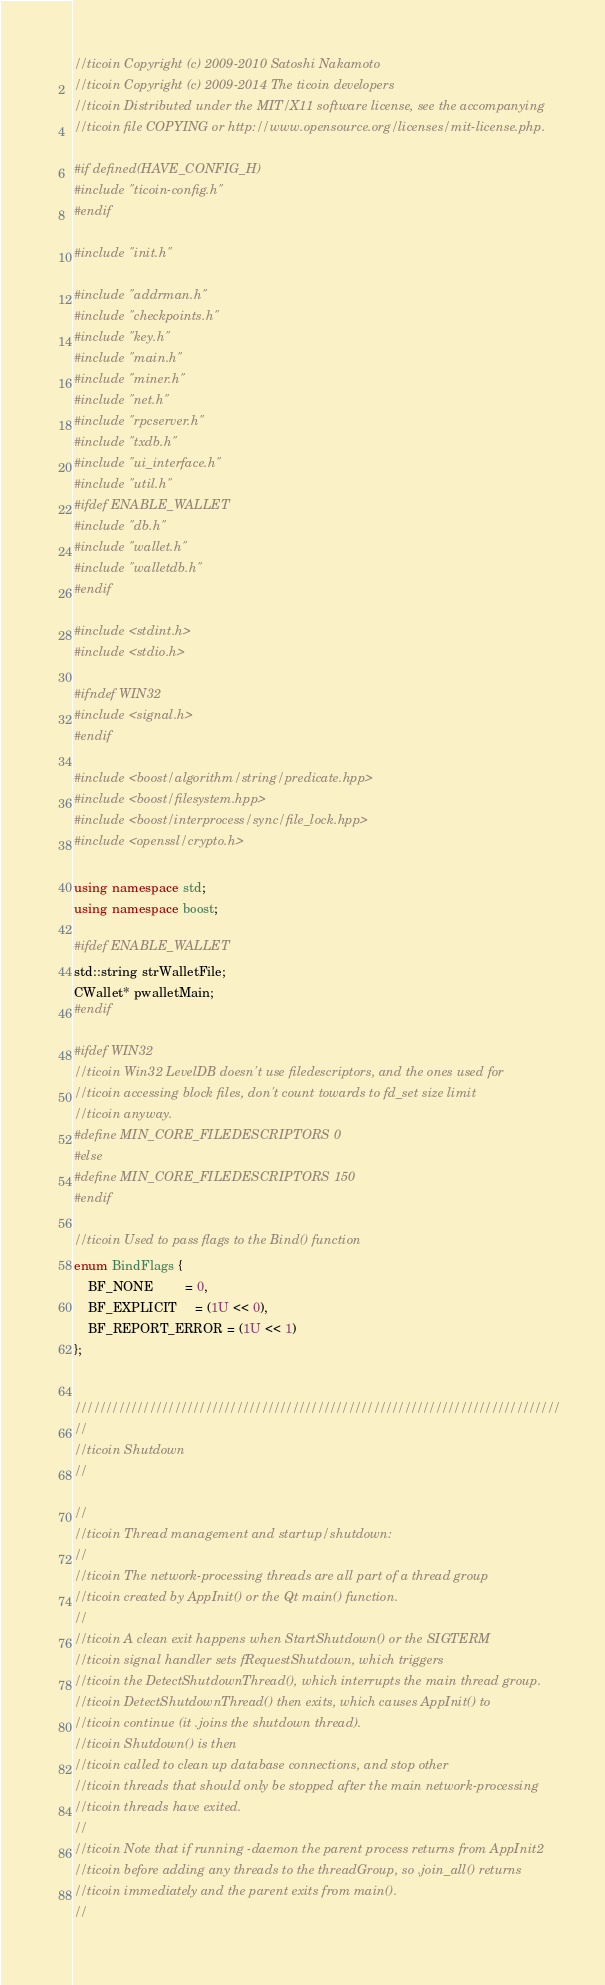<code> <loc_0><loc_0><loc_500><loc_500><_C++_>//ticoin Copyright (c) 2009-2010 Satoshi Nakamoto
//ticoin Copyright (c) 2009-2014 The ticoin developers
//ticoin Distributed under the MIT/X11 software license, see the accompanying
//ticoin file COPYING or http://www.opensource.org/licenses/mit-license.php.

#if defined(HAVE_CONFIG_H)
#include "ticoin-config.h"
#endif

#include "init.h"

#include "addrman.h"
#include "checkpoints.h"
#include "key.h"
#include "main.h"
#include "miner.h"
#include "net.h"
#include "rpcserver.h"
#include "txdb.h"
#include "ui_interface.h"
#include "util.h"
#ifdef ENABLE_WALLET
#include "db.h"
#include "wallet.h"
#include "walletdb.h"
#endif

#include <stdint.h>
#include <stdio.h>

#ifndef WIN32
#include <signal.h>
#endif

#include <boost/algorithm/string/predicate.hpp>
#include <boost/filesystem.hpp>
#include <boost/interprocess/sync/file_lock.hpp>
#include <openssl/crypto.h>

using namespace std;
using namespace boost;

#ifdef ENABLE_WALLET
std::string strWalletFile;
CWallet* pwalletMain;
#endif

#ifdef WIN32
//ticoin Win32 LevelDB doesn't use filedescriptors, and the ones used for
//ticoin accessing block files, don't count towards to fd_set size limit
//ticoin anyway.
#define MIN_CORE_FILEDESCRIPTORS 0
#else
#define MIN_CORE_FILEDESCRIPTORS 150
#endif

//ticoin Used to pass flags to the Bind() function
enum BindFlags {
    BF_NONE         = 0,
    BF_EXPLICIT     = (1U << 0),
    BF_REPORT_ERROR = (1U << 1)
};


//////////////////////////////////////////////////////////////////////////////
//
//ticoin Shutdown
//

//
//ticoin Thread management and startup/shutdown:
//
//ticoin The network-processing threads are all part of a thread group
//ticoin created by AppInit() or the Qt main() function.
//
//ticoin A clean exit happens when StartShutdown() or the SIGTERM
//ticoin signal handler sets fRequestShutdown, which triggers
//ticoin the DetectShutdownThread(), which interrupts the main thread group.
//ticoin DetectShutdownThread() then exits, which causes AppInit() to
//ticoin continue (it .joins the shutdown thread).
//ticoin Shutdown() is then
//ticoin called to clean up database connections, and stop other
//ticoin threads that should only be stopped after the main network-processing
//ticoin threads have exited.
//
//ticoin Note that if running -daemon the parent process returns from AppInit2
//ticoin before adding any threads to the threadGroup, so .join_all() returns
//ticoin immediately and the parent exits from main().
//</code> 